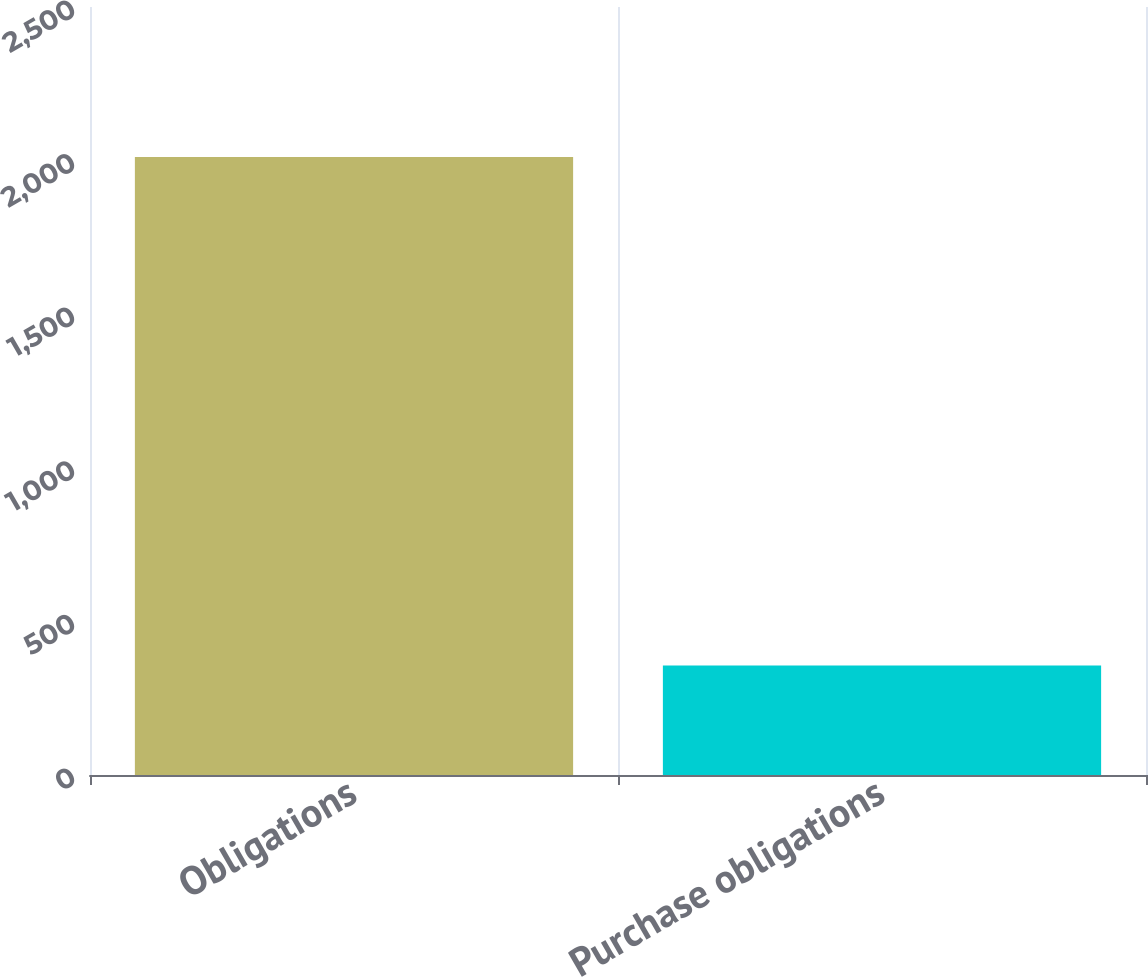<chart> <loc_0><loc_0><loc_500><loc_500><bar_chart><fcel>Obligations<fcel>Purchase obligations<nl><fcel>2012<fcel>356.1<nl></chart> 